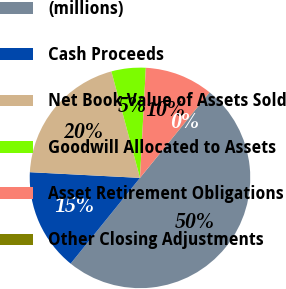Convert chart to OTSL. <chart><loc_0><loc_0><loc_500><loc_500><pie_chart><fcel>(millions)<fcel>Cash Proceeds<fcel>Net Book Value of Assets Sold<fcel>Goodwill Allocated to Assets<fcel>Asset Retirement Obligations<fcel>Other Closing Adjustments<nl><fcel>49.95%<fcel>15.0%<fcel>20.0%<fcel>5.02%<fcel>10.01%<fcel>0.02%<nl></chart> 